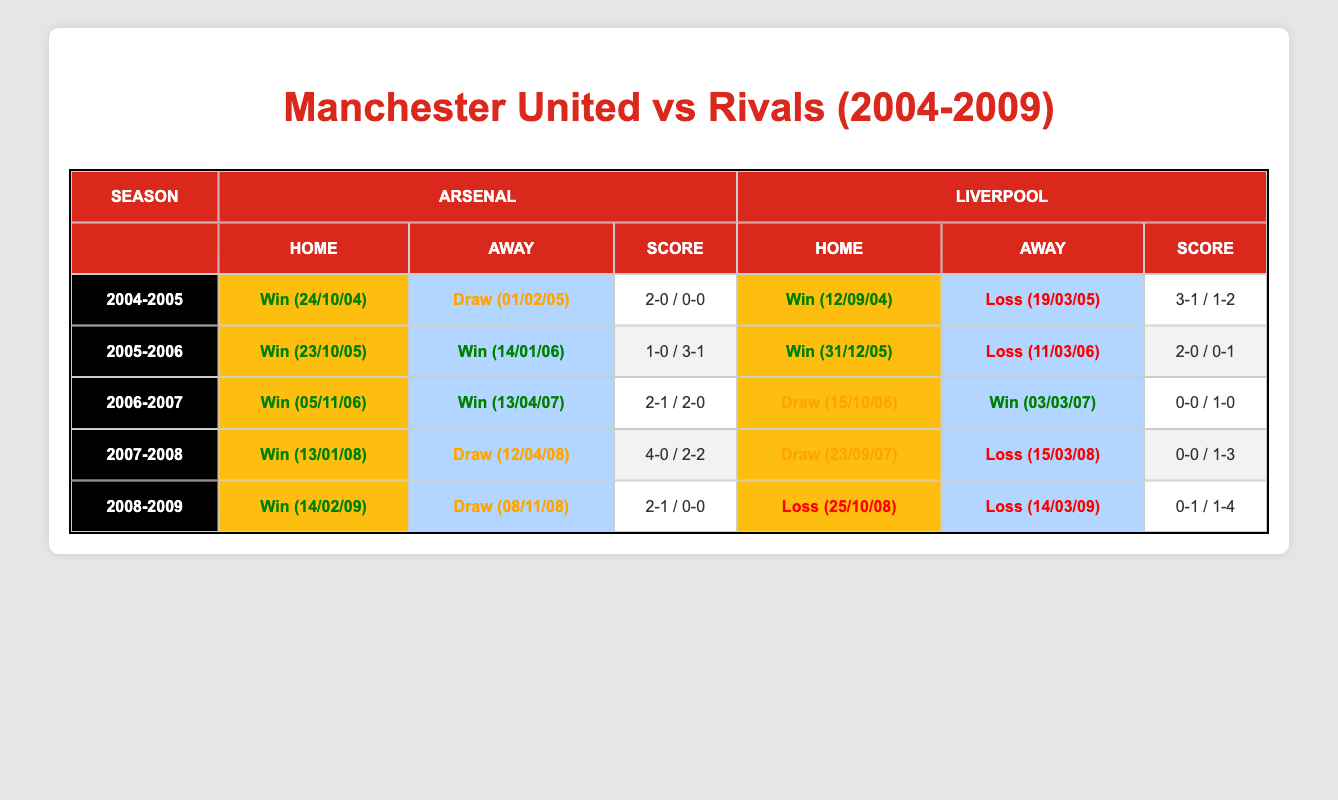What was the result of the home match against Arsenal in the 2007-2008 season? In the 2007-2008 season, Manchester United played Arsenal at home on January 13, 2008, and the result was a win with a score of 4-0.
Answer: Win (4-0) How many total wins did Manchester United achieve against Liverpool during Rooney's tenure? Manchester United had 4 wins against Liverpool in the seasons listed: 2004-2005 (1), 2005-2006 (1), 2006-2007 (1), and 2007-2008 (1). 2008-2009 had no wins. Therefore, 1+1+1+1 = 4.
Answer: 4 Did Manchester United ever lose against Arsenal at home during Rooney's tenure? No, Manchester United did not lose a home match against Arsenal during Rooney's tenure, as all home matches resulted in either a win or a draw.
Answer: No Which season had the highest number of wins against Arsenal? In the 2006-2007 season, Manchester United won both their home and away matches, thus achieving 2 wins against Arsenal, which is the highest number in the table data.
Answer: 2006-2007 What was the score difference in the match against Liverpool away in the 2008-2009 season? In the 2008-2009 season, the away match against Liverpool resulted in a loss with a score of 1-4. The score difference is calculated as 4 - 1 = 3.
Answer: 3 How many matches did Manchester United draw against Arsenal during Rooney's tenure? Manchester United drew 2 matches against Arsenal: one in the 2005-2006 season away and one in the 2007-2008 season away. Therefore, the total number of drawn matches is 2.
Answer: 2 Was there a season where Manchester United lost more than they won against Liverpool? Yes, in the 2008-2009 season, Manchester United lost both matches against Liverpool (1 at home and 1 away) and had no wins, resulting in a scenario where they lost more than they won.
Answer: Yes Which season had a perfect record against Arsenal? The 2006-2007 season had a perfect record against Arsenal, where Manchester United won both home and away matches, marking a total of 2 wins.
Answer: 2006-2007 In total, how many matches did Manchester United play against Liverpool during Rooney's tenure? Manchester United played 6 matches against Liverpool: 3 at home and 3 away across the 5 seasons listed.
Answer: 6 